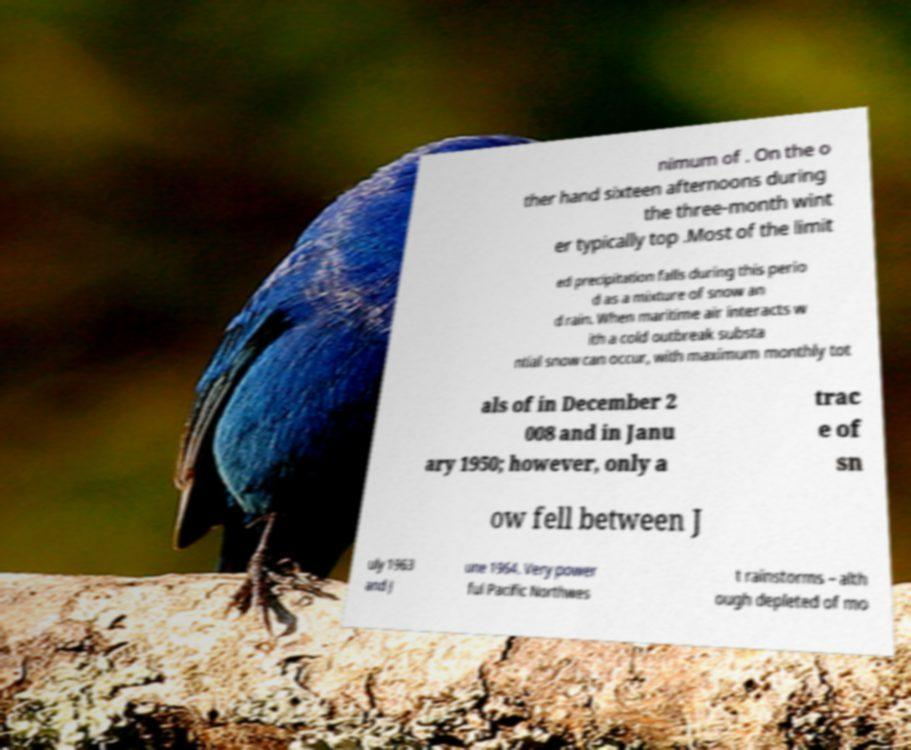There's text embedded in this image that I need extracted. Can you transcribe it verbatim? nimum of . On the o ther hand sixteen afternoons during the three-month wint er typically top .Most of the limit ed precipitation falls during this perio d as a mixture of snow an d rain. When maritime air interacts w ith a cold outbreak substa ntial snow can occur, with maximum monthly tot als of in December 2 008 and in Janu ary 1950; however, only a trac e of sn ow fell between J uly 1963 and J une 1964. Very power ful Pacific Northwes t rainstorms – alth ough depleted of mo 